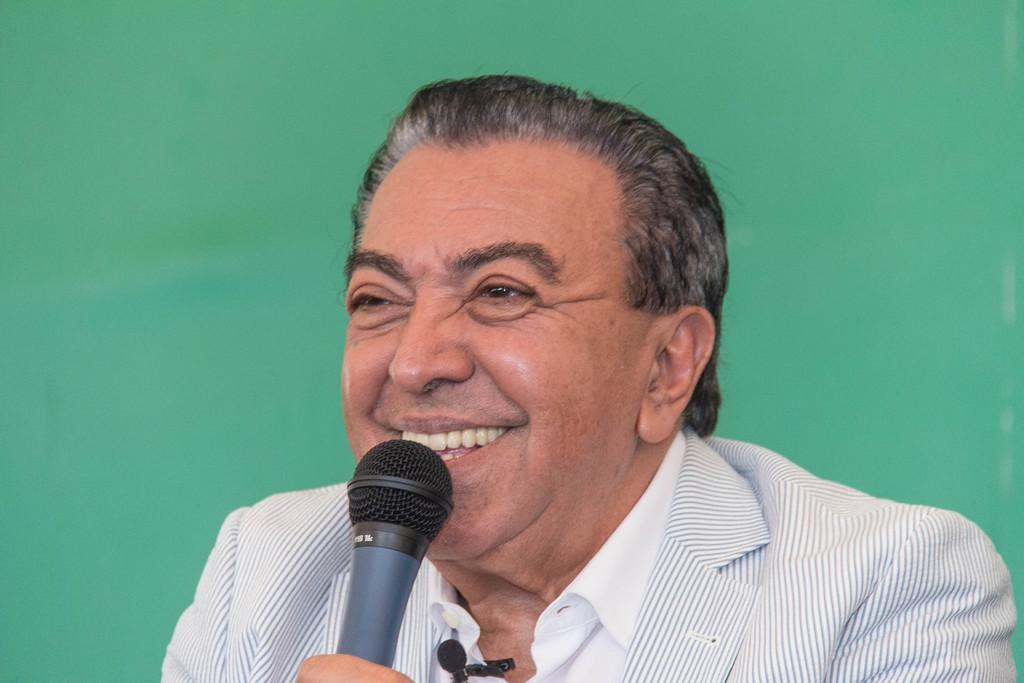What is the main subject of the image? There is a person in the image. What is the person holding in the image? The person is holding a microphone. What color is the background of the image? The background of the image is green. Can you see a hill in the background of the image? There is no hill visible in the background of the image; it is green. What type of paste is being used by the person in the image? There is no paste present in the image; the person is holding a microphone. 